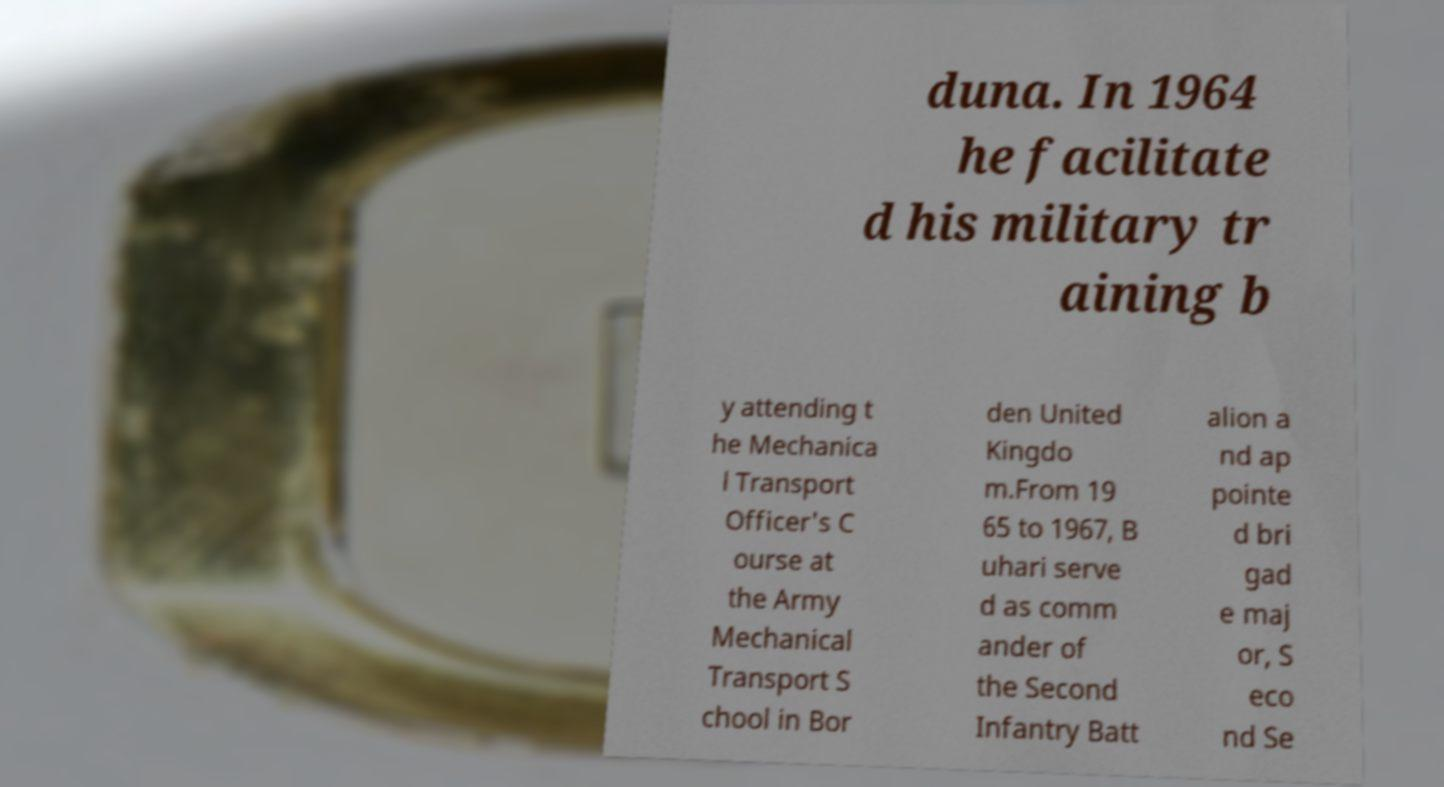Could you extract and type out the text from this image? duna. In 1964 he facilitate d his military tr aining b y attending t he Mechanica l Transport Officer's C ourse at the Army Mechanical Transport S chool in Bor den United Kingdo m.From 19 65 to 1967, B uhari serve d as comm ander of the Second Infantry Batt alion a nd ap pointe d bri gad e maj or, S eco nd Se 